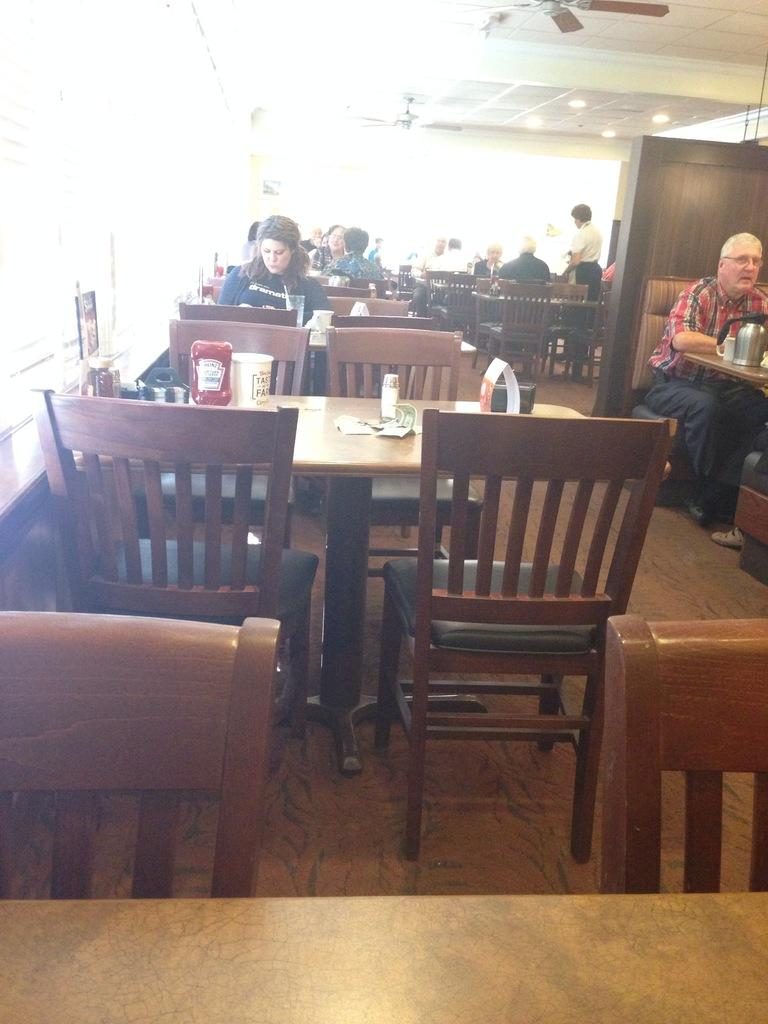What are the people in the image doing? The people in the image are sitting on chairs. What is on the table in the image? There is ketchup and a glass on the table in the image. What word is being used to describe the process of cooking a turkey in the image? There is no mention of cooking a turkey or any related process in the image. 